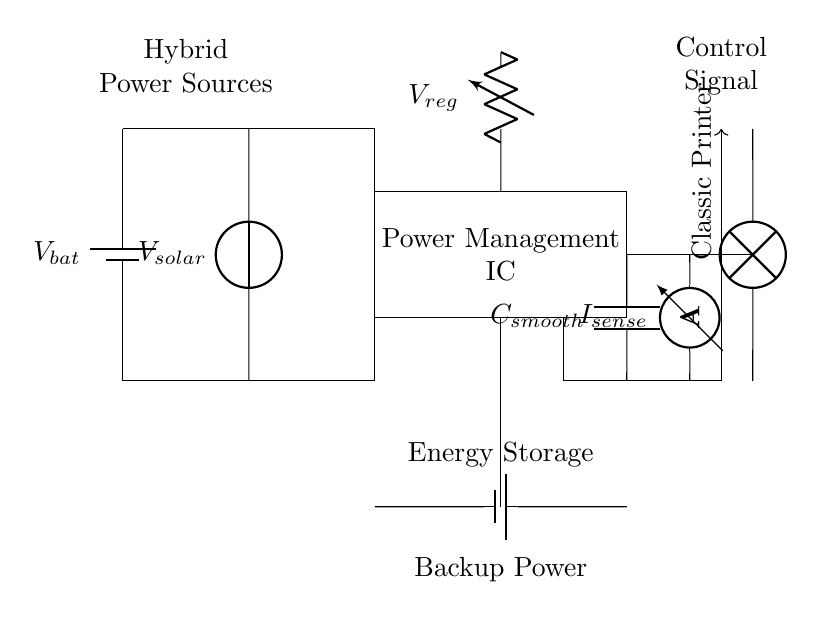What are the types of power sources in the circuit? The circuit includes a battery and a solar voltage source, indicating hybrid power sources.
Answer: battery, solar What component regulates the voltage in this circuit? The voltage regulator is responsible for regulating the output voltage from the power management IC to ensure stable operation of the load.
Answer: voltage regulator What is the purpose of the capacitor in this circuit? The capacitor smooths out voltage fluctuations, providing a more stable voltage output to the load by minimizing ripple or noise.
Answer: smoothing What is the role of the current sensor in this circuit? The current sensor monitors the current flowing to the printer, allowing for better management of the energy being used and ensuring that the power supply is adequate.
Answer: monitoring current How does the power management IC interact with the power sources? The power management IC combines the outputs from the battery and solar panel to efficiently supply power to the connected load, optimizing energy use from both sources.
Answer: combine power sources What does the control signal signify in this circuit? The control signal regulates the operation and switching between the energy sources, ensuring that the circuit operates efficiently under varying conditions and loads.
Answer: regulate operation What is the significance of having backup power in this circuit? Backup power, provided by the battery, ensures that the printer can continue to operate during periods when solar power is insufficient, ensuring reliability.
Answer: reliability 